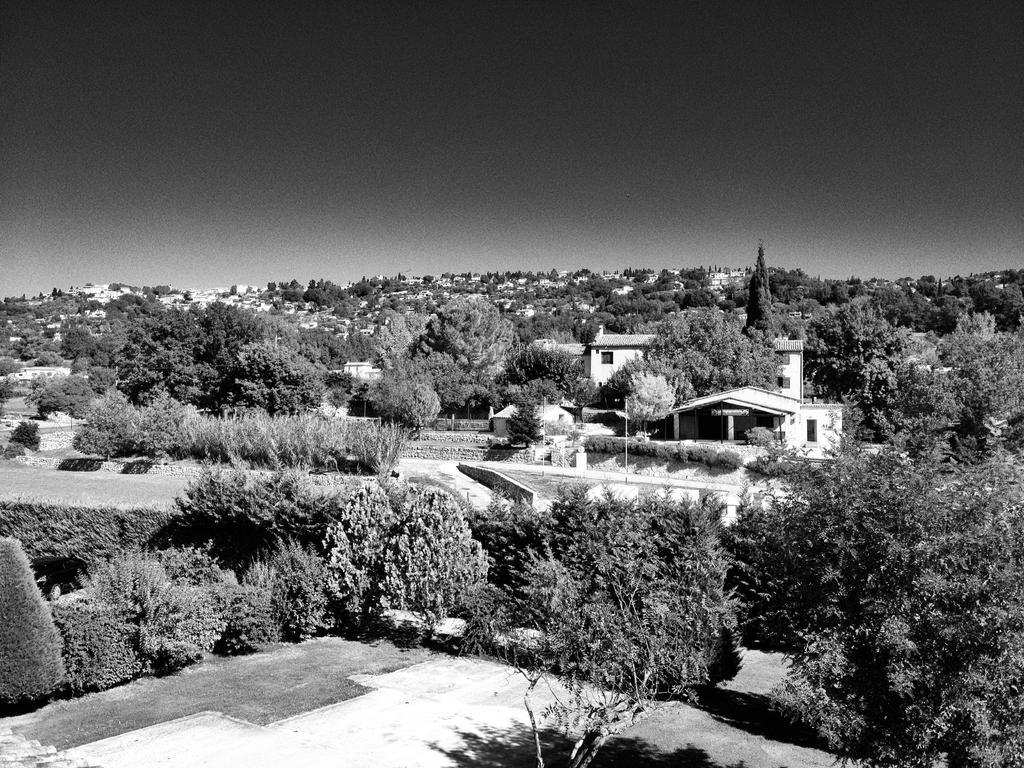What is the color scheme of the image? The image is black and white. What type of natural elements can be seen in the image? There are trees and plants in the image. What type of man-made structures are present in the image? There are houses in the image. What part of the natural environment is visible in the image? The ground and the sky are visible in the image. What type of behavior is exhibited by the father in the image? There is no father present in the image, as it only features trees, plants, houses, ground, and sky. What type of polish is used on the leaves of the plants in the image? There is no mention of any polish being used on the leaves of the plants in the image; they appear to be in their natural state. 